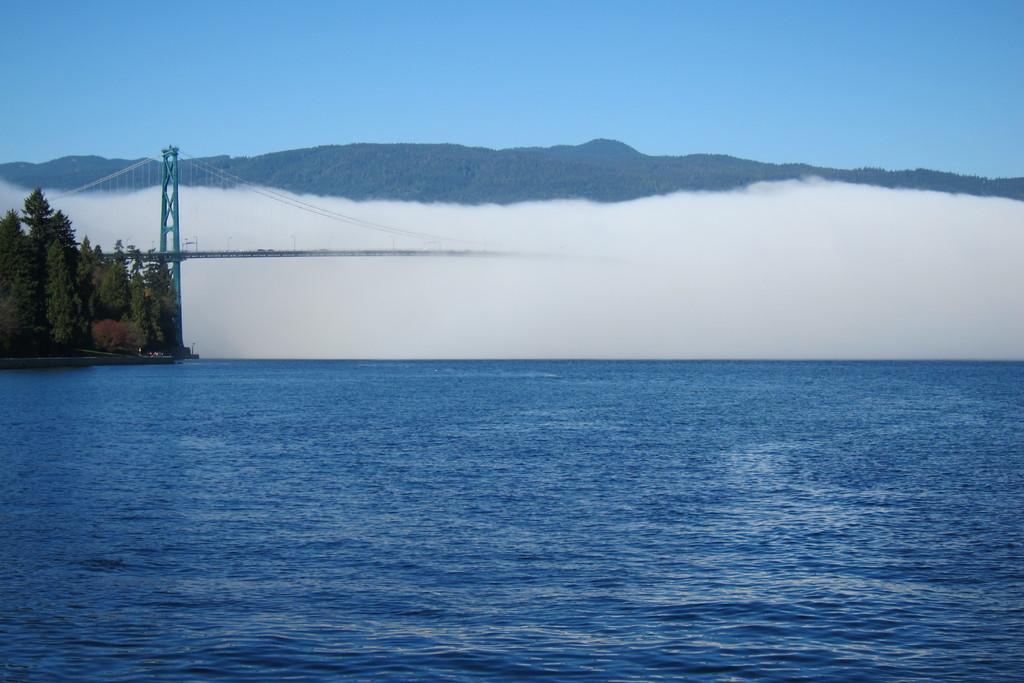Can you describe this image briefly? In this image in the front there is an ocean. In the background there are trees, there is a bridge and there are mountains. 